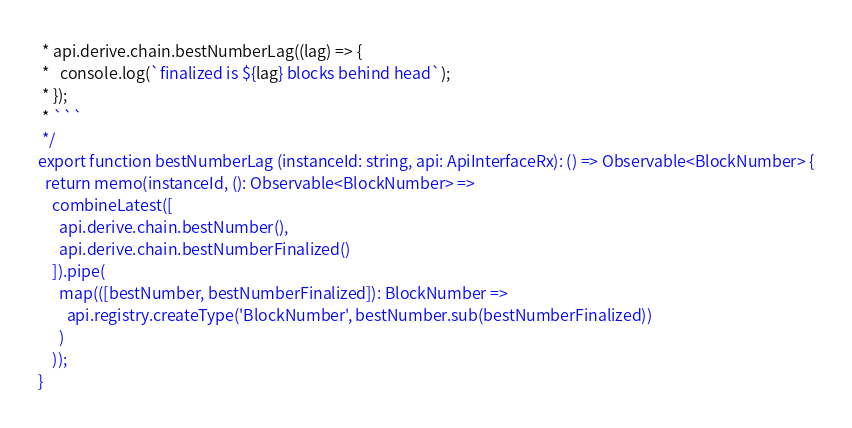<code> <loc_0><loc_0><loc_500><loc_500><_TypeScript_> * api.derive.chain.bestNumberLag((lag) => {
 *   console.log(`finalized is ${lag} blocks behind head`);
 * });
 * ```
 */
export function bestNumberLag (instanceId: string, api: ApiInterfaceRx): () => Observable<BlockNumber> {
  return memo(instanceId, (): Observable<BlockNumber> =>
    combineLatest([
      api.derive.chain.bestNumber(),
      api.derive.chain.bestNumberFinalized()
    ]).pipe(
      map(([bestNumber, bestNumberFinalized]): BlockNumber =>
        api.registry.createType('BlockNumber', bestNumber.sub(bestNumberFinalized))
      )
    ));
}
</code> 